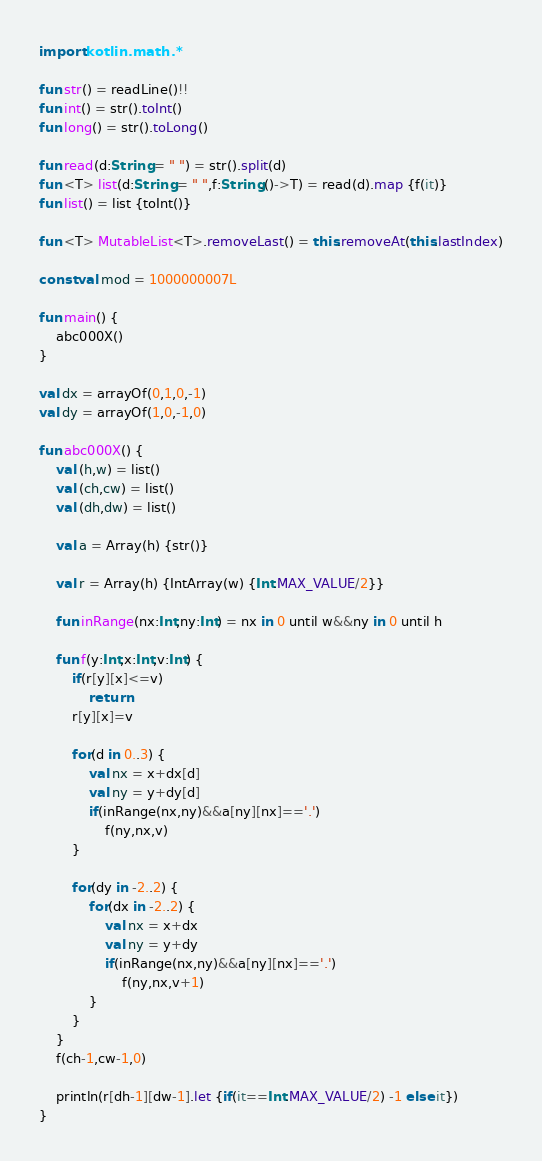Convert code to text. <code><loc_0><loc_0><loc_500><loc_500><_Kotlin_>import kotlin.math.*

fun str() = readLine()!!
fun int() = str().toInt()
fun long() = str().toLong()

fun read(d:String = " ") = str().split(d)
fun <T> list(d:String = " ",f:String.()->T) = read(d).map {f(it)}
fun list() = list {toInt()}

fun <T> MutableList<T>.removeLast() = this.removeAt(this.lastIndex)

const val mod = 1000000007L

fun main() {
	abc000X()
}

val dx = arrayOf(0,1,0,-1)
val dy = arrayOf(1,0,-1,0)

fun abc000X() {
	val (h,w) = list()
	val (ch,cw) = list()
	val (dh,dw) = list()

	val a = Array(h) {str()}

	val r = Array(h) {IntArray(w) {Int.MAX_VALUE/2}}

	fun inRange(nx:Int,ny:Int) = nx in 0 until w&&ny in 0 until h

	fun f(y:Int,x:Int,v:Int) {
		if(r[y][x]<=v)
			return
		r[y][x]=v

		for(d in 0..3) {
			val nx = x+dx[d]
			val ny = y+dy[d]
			if(inRange(nx,ny)&&a[ny][nx]=='.')
				f(ny,nx,v)
		}

		for(dy in -2..2) {
			for(dx in -2..2) {
				val nx = x+dx
				val ny = y+dy
				if(inRange(nx,ny)&&a[ny][nx]=='.')
					f(ny,nx,v+1)
			}
		}
	}
	f(ch-1,cw-1,0)

	println(r[dh-1][dw-1].let {if(it==Int.MAX_VALUE/2) -1 else it})
}
</code> 